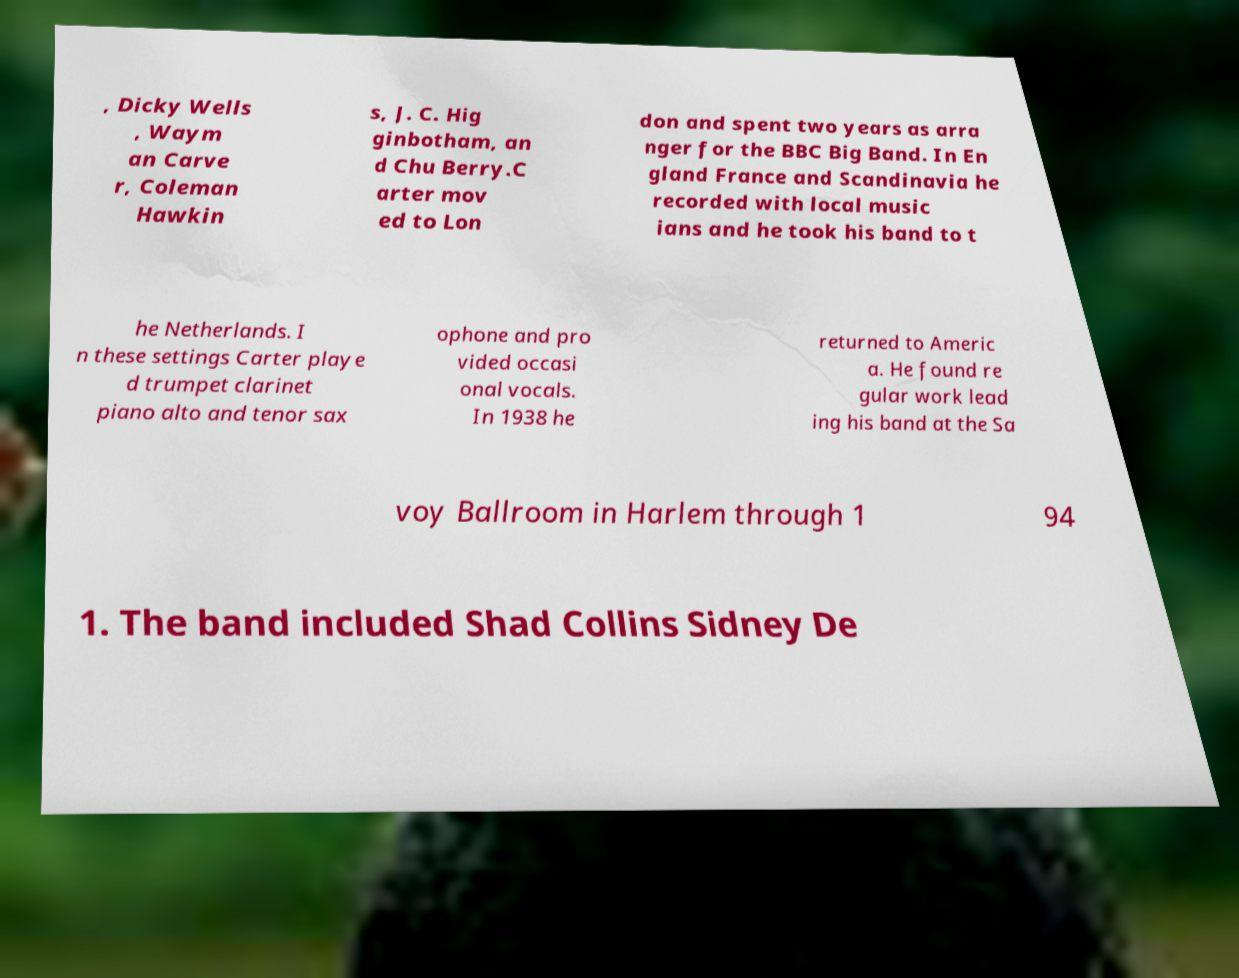Can you read and provide the text displayed in the image?This photo seems to have some interesting text. Can you extract and type it out for me? , Dicky Wells , Waym an Carve r, Coleman Hawkin s, J. C. Hig ginbotham, an d Chu Berry.C arter mov ed to Lon don and spent two years as arra nger for the BBC Big Band. In En gland France and Scandinavia he recorded with local music ians and he took his band to t he Netherlands. I n these settings Carter playe d trumpet clarinet piano alto and tenor sax ophone and pro vided occasi onal vocals. In 1938 he returned to Americ a. He found re gular work lead ing his band at the Sa voy Ballroom in Harlem through 1 94 1. The band included Shad Collins Sidney De 